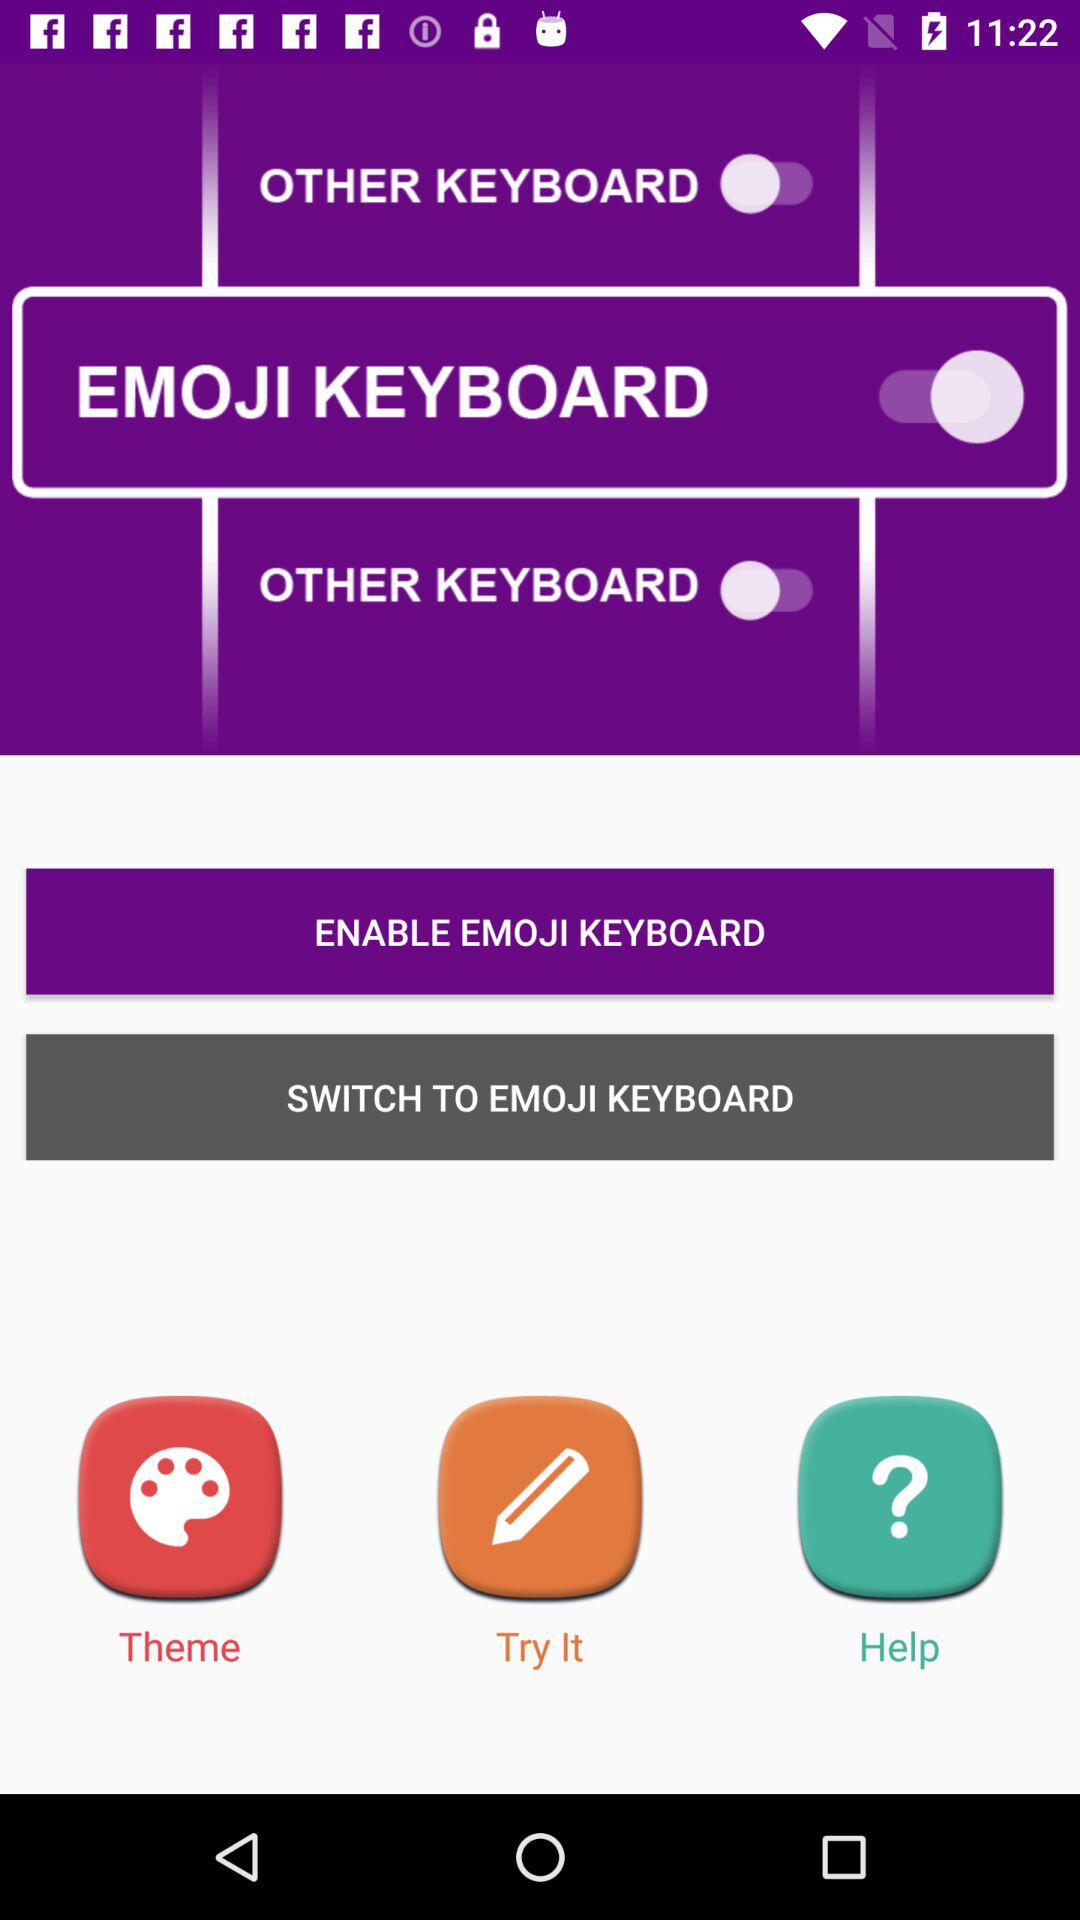What is the name of the application?
When the provided information is insufficient, respond with <no answer>. <no answer> 